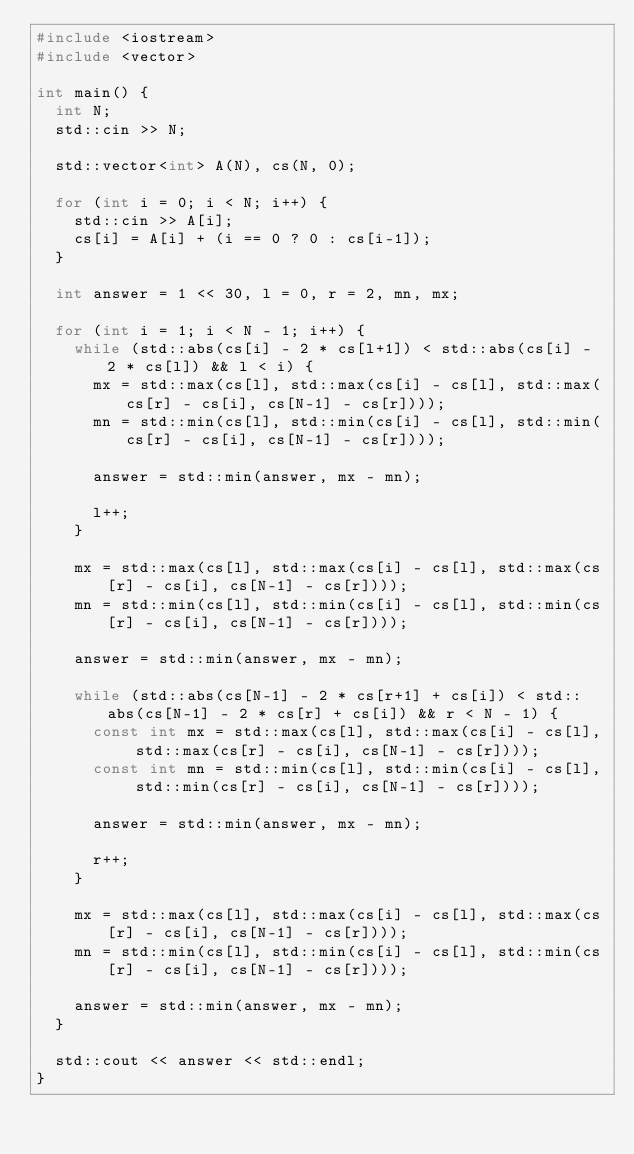<code> <loc_0><loc_0><loc_500><loc_500><_C++_>#include <iostream>
#include <vector>

int main() {
  int N;
  std::cin >> N;

  std::vector<int> A(N), cs(N, 0);

  for (int i = 0; i < N; i++) {
    std::cin >> A[i];
    cs[i] = A[i] + (i == 0 ? 0 : cs[i-1]);
  }

  int answer = 1 << 30, l = 0, r = 2, mn, mx;

  for (int i = 1; i < N - 1; i++) {
    while (std::abs(cs[i] - 2 * cs[l+1]) < std::abs(cs[i] - 2 * cs[l]) && l < i) {
      mx = std::max(cs[l], std::max(cs[i] - cs[l], std::max(cs[r] - cs[i], cs[N-1] - cs[r])));
      mn = std::min(cs[l], std::min(cs[i] - cs[l], std::min(cs[r] - cs[i], cs[N-1] - cs[r])));

      answer = std::min(answer, mx - mn);

      l++;
    }

    mx = std::max(cs[l], std::max(cs[i] - cs[l], std::max(cs[r] - cs[i], cs[N-1] - cs[r])));
    mn = std::min(cs[l], std::min(cs[i] - cs[l], std::min(cs[r] - cs[i], cs[N-1] - cs[r])));

    answer = std::min(answer, mx - mn);

    while (std::abs(cs[N-1] - 2 * cs[r+1] + cs[i]) < std::abs(cs[N-1] - 2 * cs[r] + cs[i]) && r < N - 1) {
      const int mx = std::max(cs[l], std::max(cs[i] - cs[l], std::max(cs[r] - cs[i], cs[N-1] - cs[r])));
      const int mn = std::min(cs[l], std::min(cs[i] - cs[l], std::min(cs[r] - cs[i], cs[N-1] - cs[r])));

      answer = std::min(answer, mx - mn);

      r++;
    }

    mx = std::max(cs[l], std::max(cs[i] - cs[l], std::max(cs[r] - cs[i], cs[N-1] - cs[r])));
    mn = std::min(cs[l], std::min(cs[i] - cs[l], std::min(cs[r] - cs[i], cs[N-1] - cs[r])));

    answer = std::min(answer, mx - mn);
  }

  std::cout << answer << std::endl;
}
</code> 